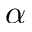Convert formula to latex. <formula><loc_0><loc_0><loc_500><loc_500>\alpha</formula> 